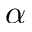Convert formula to latex. <formula><loc_0><loc_0><loc_500><loc_500>\alpha</formula> 